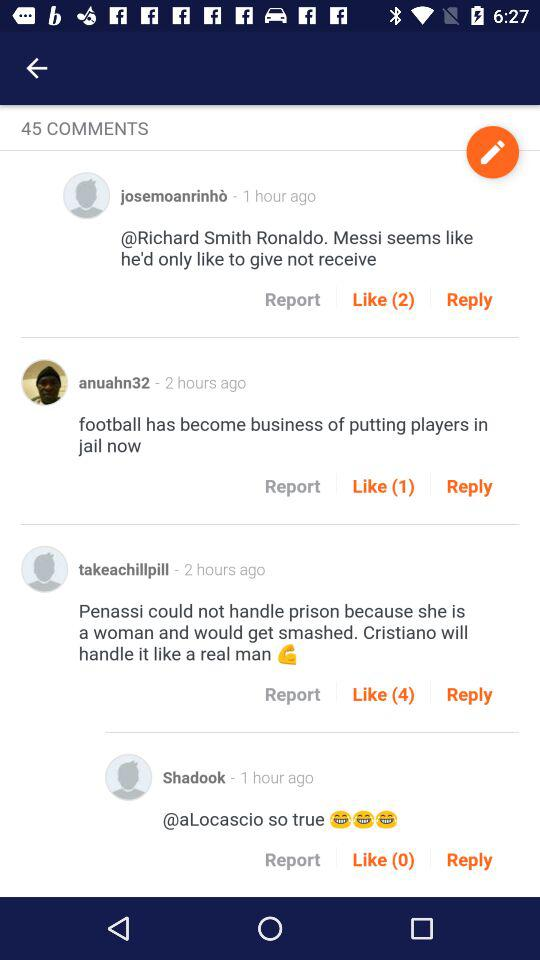What is the comment written by "anuahn32"? The written comment is "football has become business of putting players in jail now". 